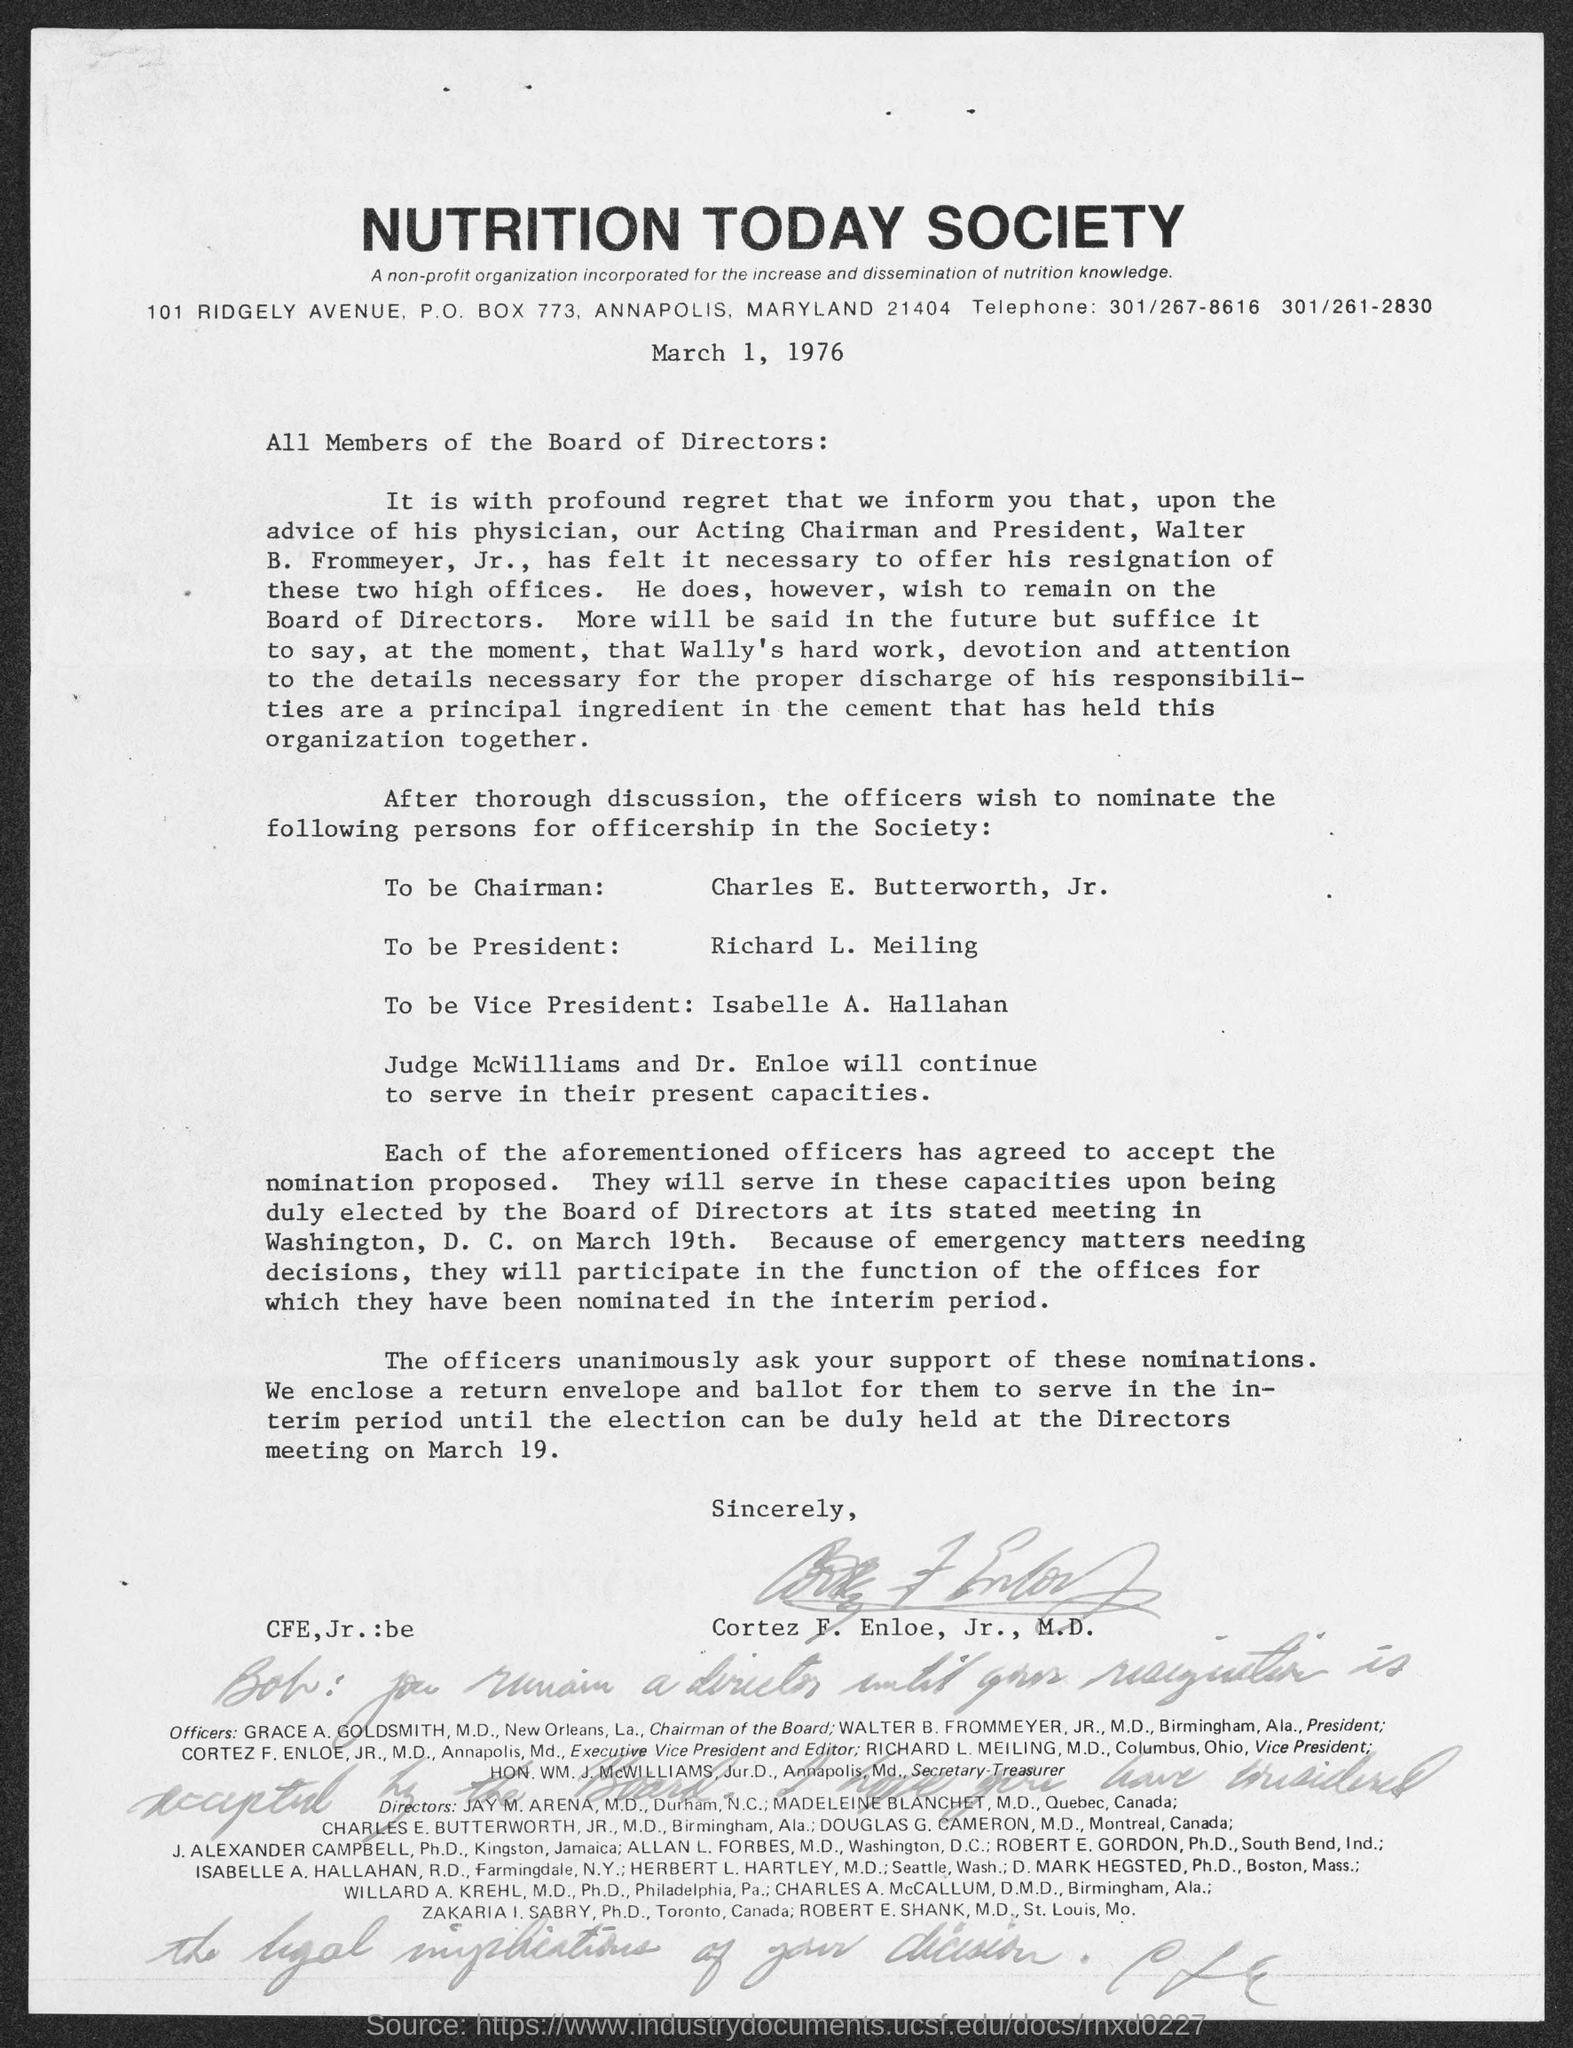Draw attention to some important aspects in this diagram. It is proposed that Richard L. Meiling be nominated for President. The individual to be nominated as Chairman is Charles E. Butterworth, Jr. The person who is to be nominated as Vice-President is Isabelle A. Hallahan. 